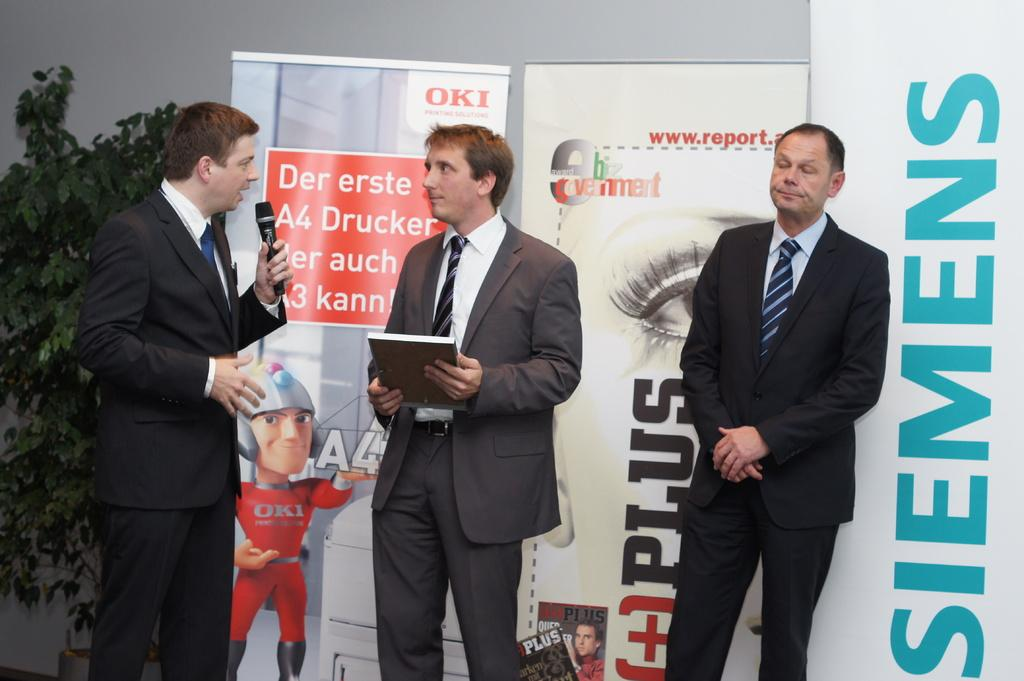How many people are on stage in the image? There are three people on stage in the image. What is one person doing with their hands? One person is holding a microphone. What is another person holding in their hands? Another person is holding a book. What can be seen behind the people on stage? There are banners visible behind the people. What type of vegetation is in the background of the image? There is a plant in the background. How does the crowd react to the person kicking the ball in the image? There is no crowd or person kicking a ball present in the image. 